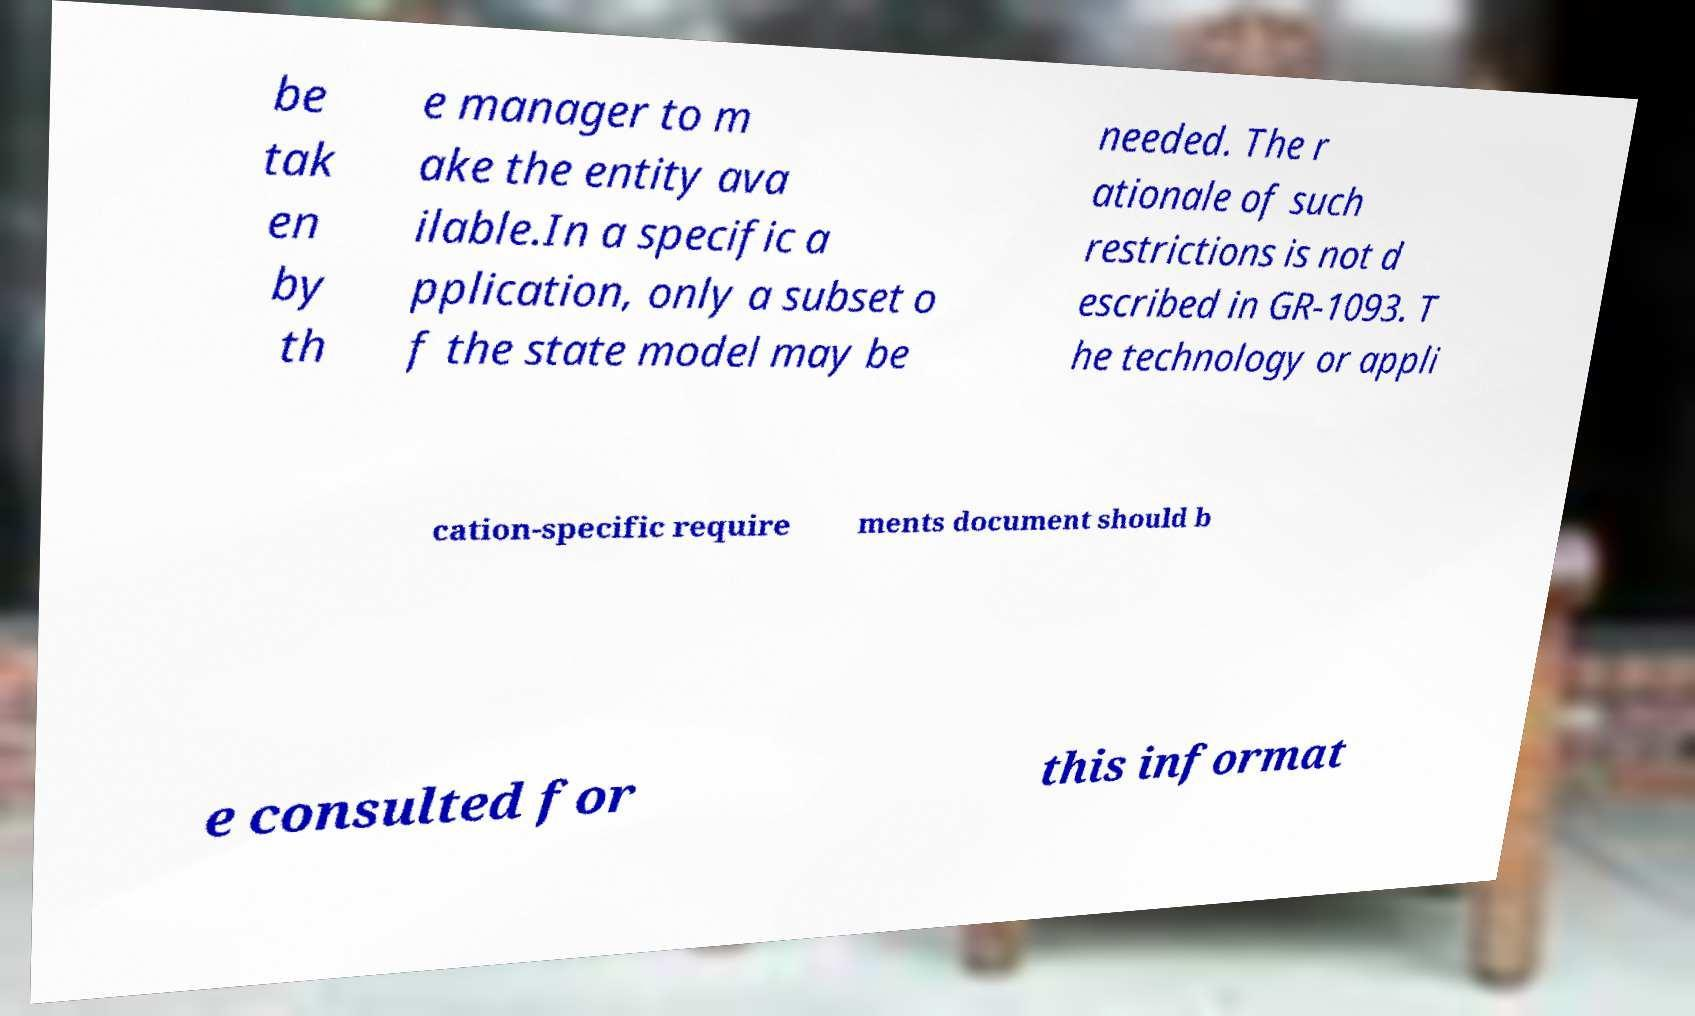Could you assist in decoding the text presented in this image and type it out clearly? be tak en by th e manager to m ake the entity ava ilable.In a specific a pplication, only a subset o f the state model may be needed. The r ationale of such restrictions is not d escribed in GR-1093. T he technology or appli cation-specific require ments document should b e consulted for this informat 